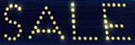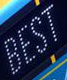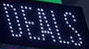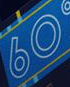What text appears in these images from left to right, separated by a semicolon? SALE; BEST; DEALS; 60 